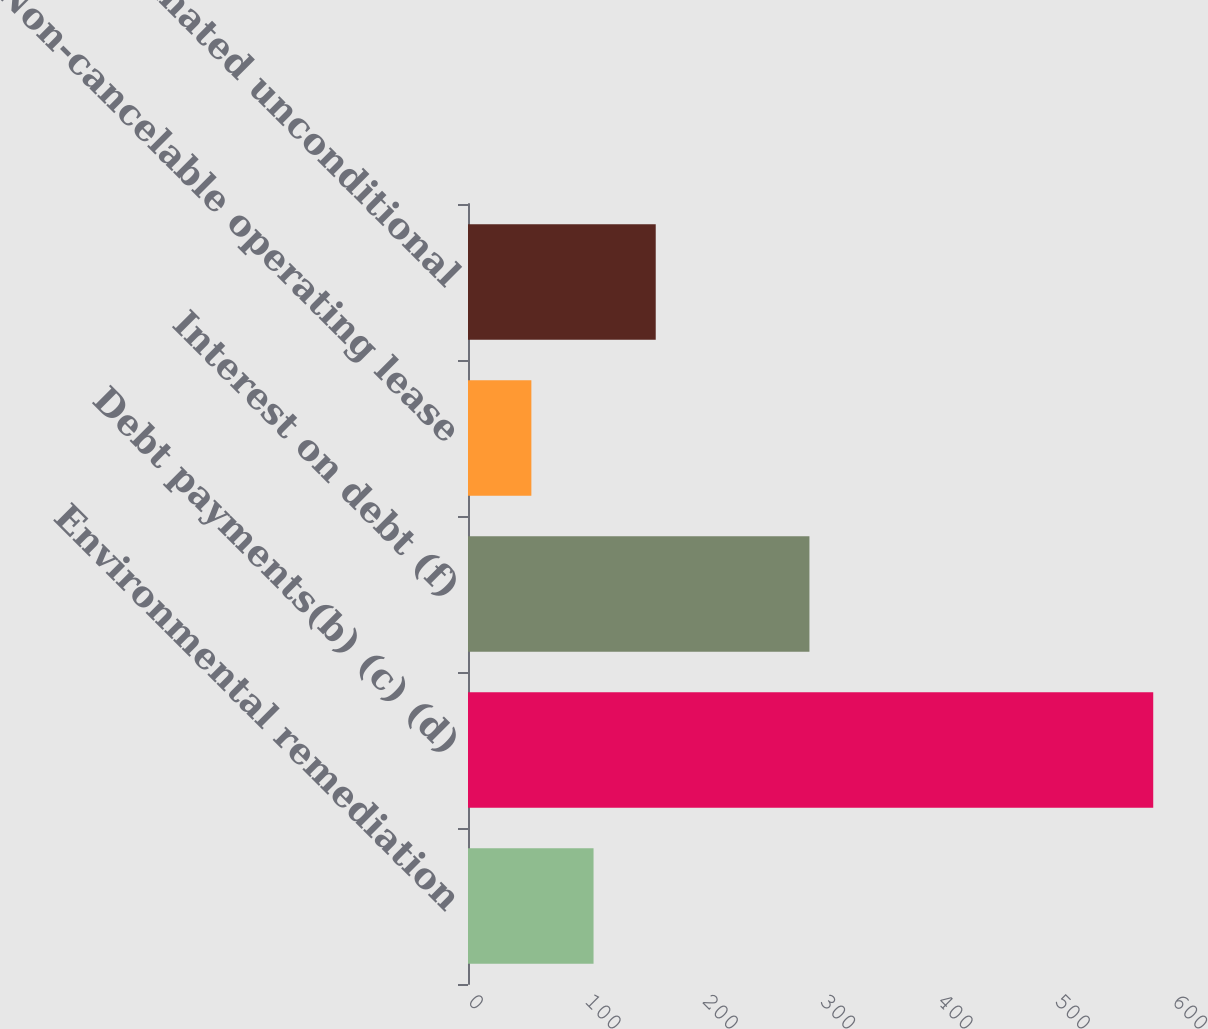Convert chart. <chart><loc_0><loc_0><loc_500><loc_500><bar_chart><fcel>Environmental remediation<fcel>Debt payments(b) (c) (d)<fcel>Interest on debt (f)<fcel>Non-cancelable operating lease<fcel>Estimated unconditional<nl><fcel>107<fcel>584<fcel>291<fcel>54<fcel>160<nl></chart> 